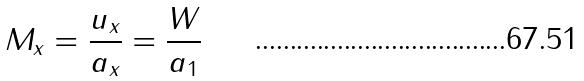Convert formula to latex. <formula><loc_0><loc_0><loc_500><loc_500>M _ { x } = \frac { u _ { x } } { a _ { x } } = \frac { W } { a _ { 1 } }</formula> 